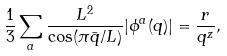<formula> <loc_0><loc_0><loc_500><loc_500>\frac { 1 } { 3 } \sum _ { a } \frac { L ^ { 2 } } { \cos ( \pi \bar { q } / L ) } | \phi ^ { a } ( q ) | = \frac { r } { q ^ { z } } ,</formula> 